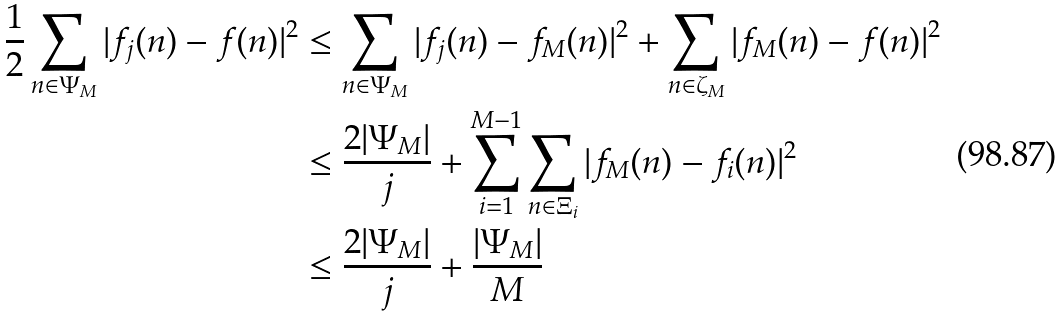<formula> <loc_0><loc_0><loc_500><loc_500>\frac { 1 } { 2 } \sum _ { n \in \Psi _ { M } } | f _ { j } ( n ) - f ( n ) | ^ { 2 } & \leq \sum _ { n \in \Psi _ { M } } | f _ { j } ( n ) - f _ { M } ( n ) | ^ { 2 } + \sum _ { n \in \zeta _ { M } } | f _ { M } ( n ) - f ( n ) | ^ { 2 } \\ & \leq \frac { 2 | \Psi _ { M } | } { j } + \sum _ { i = 1 } ^ { M - 1 } \sum _ { n \in \Xi _ { i } } | f _ { M } ( n ) - f _ { i } ( n ) | ^ { 2 } \\ & \leq \frac { 2 | \Psi _ { M } | } { j } + \frac { | \Psi _ { M } | } { M }</formula> 